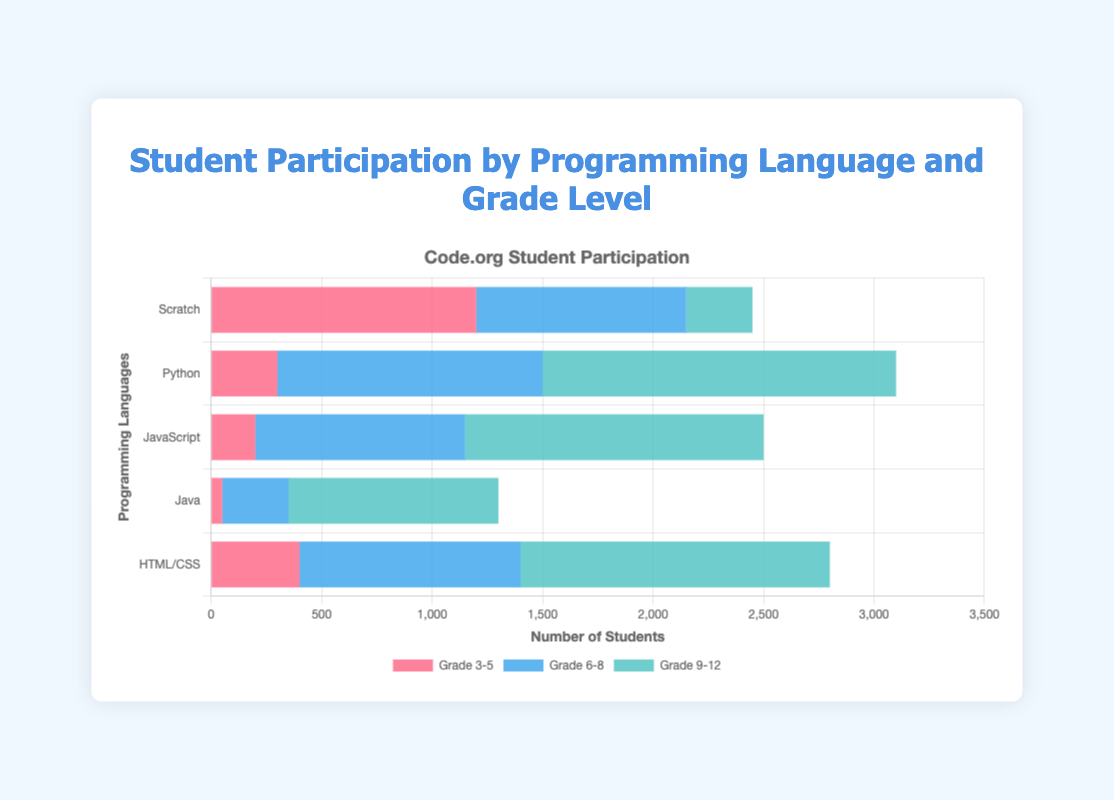What is the total student participation for Python across all grade levels? To find the total participation for Python, add the number of students from each grade level: 300 (Grade 3-5) + 1200 (Grade 6-8) + 1600 (Grade 9-12).
Answer: 3100 Which grade level has the highest participation in HTML/CSS? To identify the grade level with the highest participation in HTML/CSS, compare the numbers: 400 (Grade 3-5), 1000 (Grade 6-8), 1400 (Grade 9-12). Grade 9-12 has the highest number.
Answer: Grade 9-12 What is the difference in participation between Grade 3-5 and Grade 9-12 for JavaScript? Subtract the participation numbers for Grade 3-5 from Grade 9-12 for JavaScript: 1350 (Grade 9-12) - 200 (Grade 3-5).
Answer: 1150 Which programming language has the least participation in Grade 6-8? From the figure, compare the participation numbers in Grade 6-8: Scratch (950), Python (1200), JavaScript (950), Java (300), HTML/CSS (1000). Java has the least participation.
Answer: Java What is the average student participation for Scratch across the three grade levels? To find the average, sum the participation numbers and divide by the number of grade levels: (1200 + 950 + 300) / 3.
Answer: 816.67 Is participation in Scratch higher in Grade 3-5 or Grade 6-8? Compare the participation numbers for Scratch: 1200 (Grade 3-5) and 950 (Grade 6-8). Grade 3-5 has higher participation.
Answer: Grade 3-5 How does the participation for Java in Grade 9-12 compare to Python in Grade 6-8? Compare the participation numbers: Java (Grade 9-12) is 950, Python (Grade 6-8) is 1200. Python in Grade 6-8 is higher.
Answer: Python in Grade 6-8 Which grade level has the most participation across all programming languages? Sum the participation across all languages for each grade level and compare: Grade 3-5 (1200+300+200+50+400=2150), Grade 6-8 (950+1200+950+300+1000=4400), Grade 9-12 (300+1600+1350+950+1400=5600). Grade 9-12 has the most participation.
Answer: Grade 9-12 